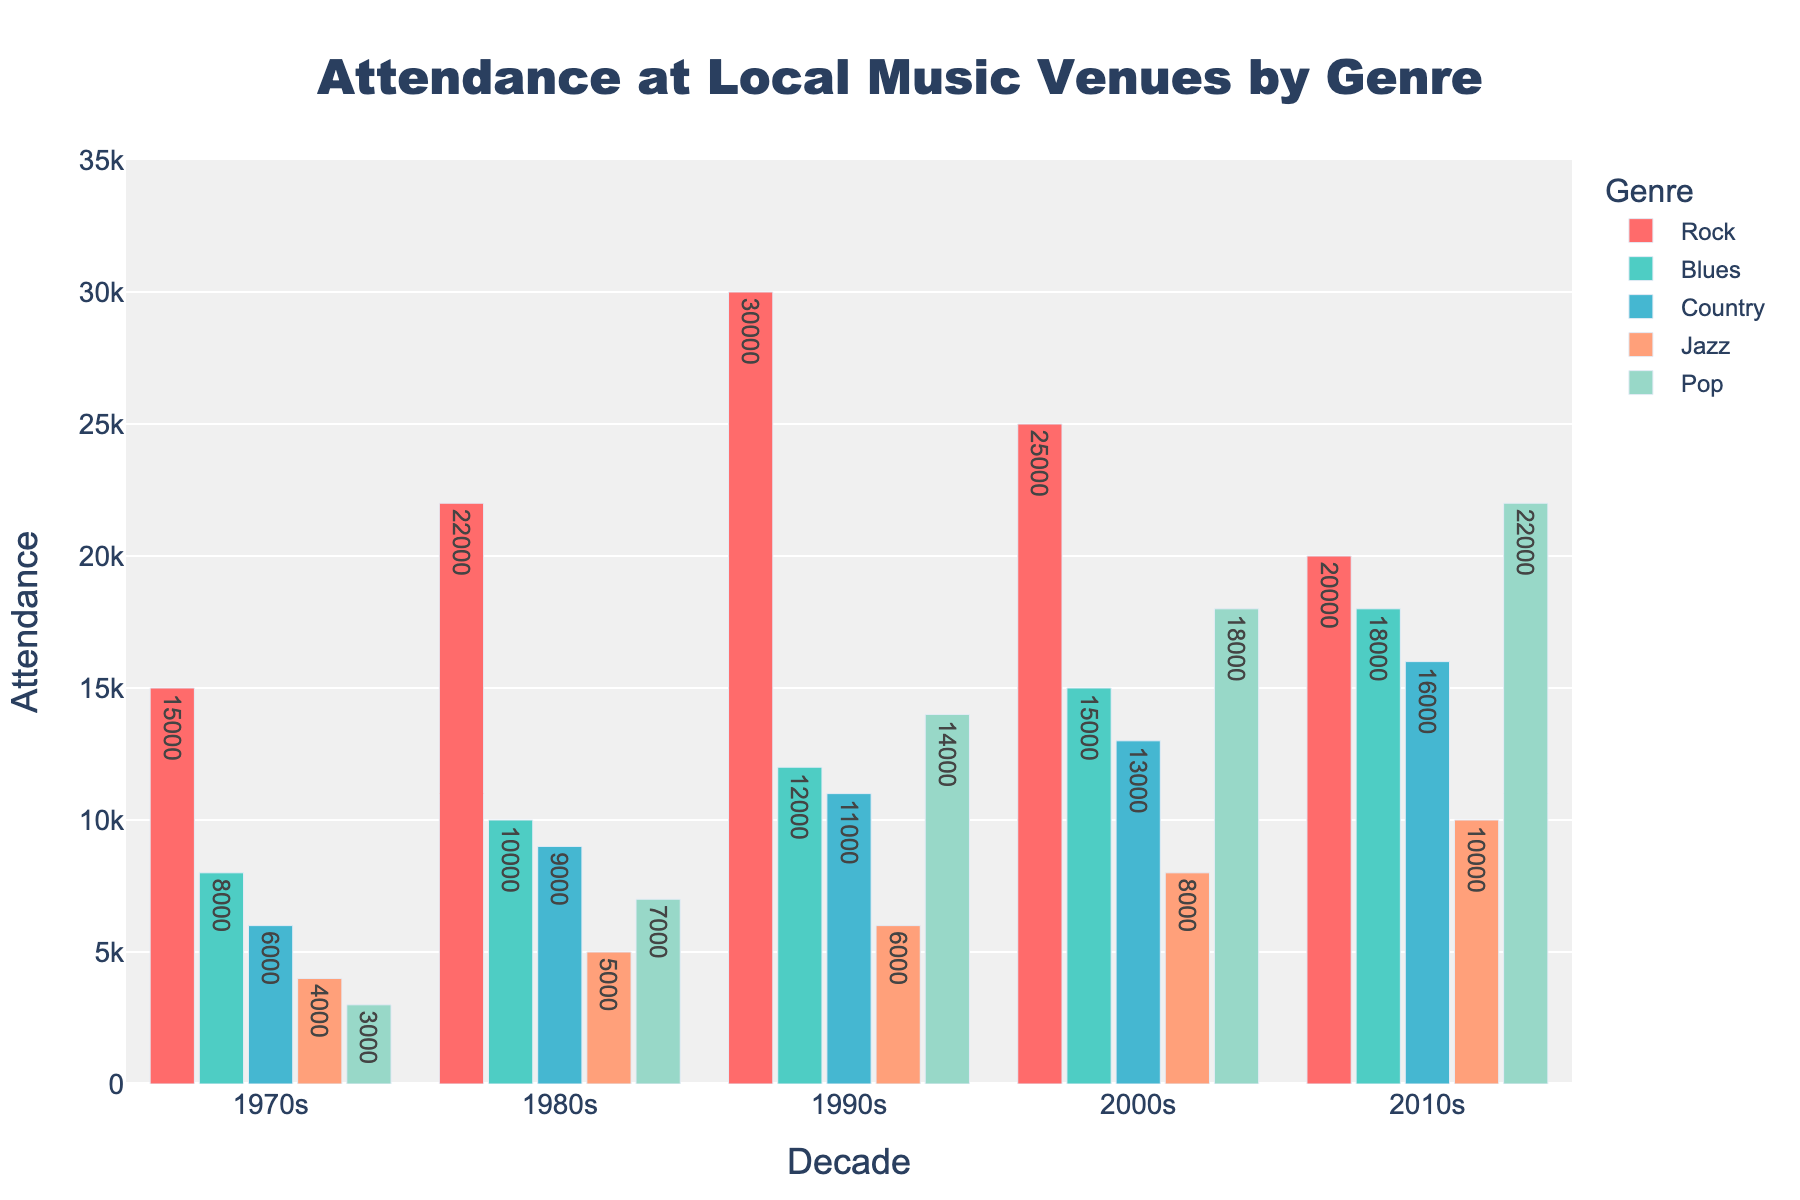Which genre has the highest attendance in the 2010s? In the 2010s, the attendance values for the genres are Rock (20,000), Blues (18,000), Country (16,000), Jazz (10,000), and Pop (22,000). Pop has the highest attendance.
Answer: Pop How much did the Rock genre's attendance increase from the 1970s to the 1990s? The attendance in the 1970s for Rock was 15,000, and in the 1990s, it was 30,000. The increase is calculated as 30,000 - 15,000 = 15,000.
Answer: 15,000 Which genre experienced the largest increase in attendance between any two consecutive decades? Comparing the differences between each decade for all genres: Rock (7,000 from 1970s to 1980s), Blues (3,000 from 2000s to 2010s), Country (3,000 from 2000s to 2010s), Jazz (2,000 from 2000s to 2010s), Pop (4,000 from 2000s to 2010s). The biggest increase is in Rock (10,000 from 1980s to 1990s).
Answer: Rock (between 1980s and 1990s) What is the total attendance of all genres in the 2000s? Add the attendance for all genres in the 2000s: Rock (25,000) + Blues (15,000) + Country (13,000) + Jazz (8,000) + Pop (18,000) = 79,000.
Answer: 79,000 Which two genres have the closest attendance figures in the 1990s? In the 1990s, Rock (30,000), Blues (12,000), Country (11,000), Jazz (6,000), and Pop (14,000). Country and Blues have the closest attendance figures: 12,000 - 11,000 = 1,000.
Answer: Country and Blues What is the average attendance for Jazz over the five decades? Calculate the sum of Jazz attendance over the five decades: 4,000 + 5,000 + 6,000 + 8,000 + 10,000 = 33,000. Divide by 5 to get the average: 33,000 / 5 = 6,600.
Answer: 6,600 In which decade did the Pop genre first surpass 10,000 in attendance? Pop attendance in each decade is 3,000 (1970s), 7,000 (1980s), 14,000 (1990s), 18,000 (2000s), and 22,000 (2010s). The first decade it surpasses 10,000 is the 1990s (14,000).
Answer: 1990s 